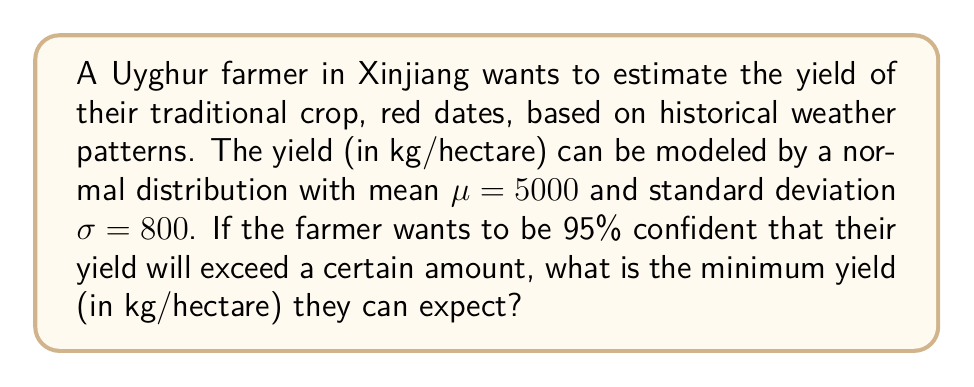Give your solution to this math problem. To solve this problem, we need to use the properties of the normal distribution and the concept of z-scores.

1) For a normal distribution, 95% of the data falls above the 5th percentile.

2) We need to find the z-score corresponding to the 5th percentile. This z-score is -1.645 (from standard normal distribution tables).

3) The formula for z-score is:
   $$z = \frac{X - \mu}{\sigma}$$

   where X is the value we're looking for, $\mu$ is the mean, and $\sigma$ is the standard deviation.

4) Substituting the known values:
   $$-1.645 = \frac{X - 5000}{800}$$

5) Solving for X:
   $$X = 5000 + (-1.645 * 800)$$
   $$X = 5000 - 1316$$
   $$X = 3684$$

6) Therefore, the farmer can be 95% confident that their yield will exceed 3684 kg/hectare.
Answer: 3684 kg/hectare 